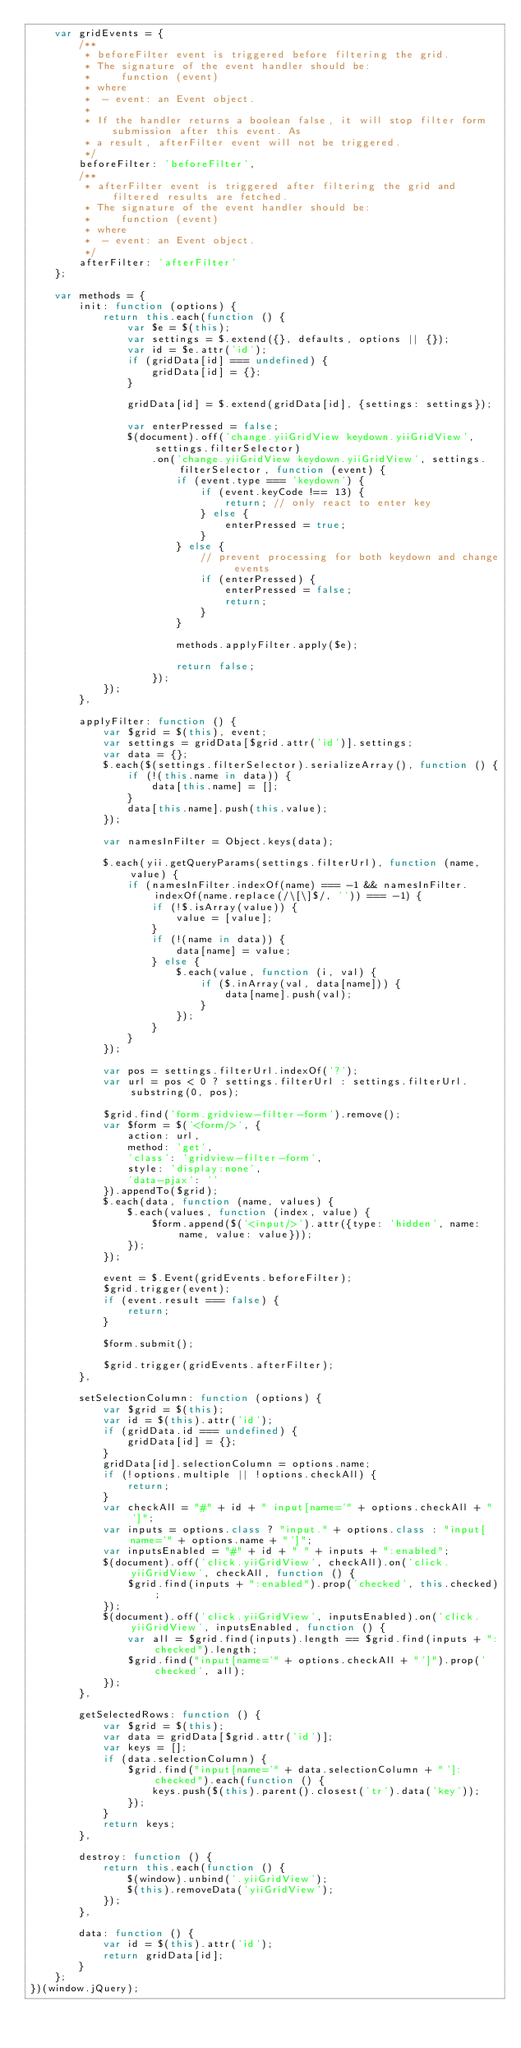<code> <loc_0><loc_0><loc_500><loc_500><_JavaScript_>    var gridEvents = {
        /**
         * beforeFilter event is triggered before filtering the grid.
         * The signature of the event handler should be:
         *     function (event)
         * where
         *  - event: an Event object.
         *
         * If the handler returns a boolean false, it will stop filter form submission after this event. As
         * a result, afterFilter event will not be triggered.
         */
        beforeFilter: 'beforeFilter',
        /**
         * afterFilter event is triggered after filtering the grid and filtered results are fetched.
         * The signature of the event handler should be:
         *     function (event)
         * where
         *  - event: an Event object.
         */
        afterFilter: 'afterFilter'
    };

    var methods = {
        init: function (options) {
            return this.each(function () {
                var $e = $(this);
                var settings = $.extend({}, defaults, options || {});
                var id = $e.attr('id');
                if (gridData[id] === undefined) {
                    gridData[id] = {};
                }

                gridData[id] = $.extend(gridData[id], {settings: settings});

                var enterPressed = false;
                $(document).off('change.yiiGridView keydown.yiiGridView', settings.filterSelector)
                    .on('change.yiiGridView keydown.yiiGridView', settings.filterSelector, function (event) {
                        if (event.type === 'keydown') {
                            if (event.keyCode !== 13) {
                                return; // only react to enter key
                            } else {
                                enterPressed = true;
                            }
                        } else {
                            // prevent processing for both keydown and change events
                            if (enterPressed) {
                                enterPressed = false;
                                return;
                            }
                        }

                        methods.applyFilter.apply($e);

                        return false;
                    });
            });
        },

        applyFilter: function () {
            var $grid = $(this), event;
            var settings = gridData[$grid.attr('id')].settings;
            var data = {};
            $.each($(settings.filterSelector).serializeArray(), function () {
                if (!(this.name in data)) {
                    data[this.name] = [];
                }
                data[this.name].push(this.value);
            });

            var namesInFilter = Object.keys(data);

            $.each(yii.getQueryParams(settings.filterUrl), function (name, value) {
                if (namesInFilter.indexOf(name) === -1 && namesInFilter.indexOf(name.replace(/\[\]$/, '')) === -1) {
                    if (!$.isArray(value)) {
                        value = [value];
                    }
                    if (!(name in data)) {
                        data[name] = value;
                    } else {
                        $.each(value, function (i, val) {
                            if ($.inArray(val, data[name])) {
                                data[name].push(val);
                            }
                        });
                    }
                }
            });

            var pos = settings.filterUrl.indexOf('?');
            var url = pos < 0 ? settings.filterUrl : settings.filterUrl.substring(0, pos);

            $grid.find('form.gridview-filter-form').remove();
            var $form = $('<form/>', {
                action: url,
                method: 'get',
                'class': 'gridview-filter-form',
                style: 'display:none',
                'data-pjax': ''
            }).appendTo($grid);
            $.each(data, function (name, values) {
                $.each(values, function (index, value) {
                    $form.append($('<input/>').attr({type: 'hidden', name: name, value: value}));
                });
            });

            event = $.Event(gridEvents.beforeFilter);
            $grid.trigger(event);
            if (event.result === false) {
                return;
            }

            $form.submit();

            $grid.trigger(gridEvents.afterFilter);
        },

        setSelectionColumn: function (options) {
            var $grid = $(this);
            var id = $(this).attr('id');
            if (gridData.id === undefined) {
                gridData[id] = {};
            }
            gridData[id].selectionColumn = options.name;
            if (!options.multiple || !options.checkAll) {
                return;
            }
            var checkAll = "#" + id + " input[name='" + options.checkAll + "']";
            var inputs = options.class ? "input." + options.class : "input[name='" + options.name + "']";
            var inputsEnabled = "#" + id + " " + inputs + ":enabled";
            $(document).off('click.yiiGridView', checkAll).on('click.yiiGridView', checkAll, function () {
                $grid.find(inputs + ":enabled").prop('checked', this.checked);
            });
            $(document).off('click.yiiGridView', inputsEnabled).on('click.yiiGridView', inputsEnabled, function () {
                var all = $grid.find(inputs).length == $grid.find(inputs + ":checked").length;
                $grid.find("input[name='" + options.checkAll + "']").prop('checked', all);
            });
        },

        getSelectedRows: function () {
            var $grid = $(this);
            var data = gridData[$grid.attr('id')];
            var keys = [];
            if (data.selectionColumn) {
                $grid.find("input[name='" + data.selectionColumn + "']:checked").each(function () {
                    keys.push($(this).parent().closest('tr').data('key'));
                });
            }
            return keys;
        },

        destroy: function () {
            return this.each(function () {
                $(window).unbind('.yiiGridView');
                $(this).removeData('yiiGridView');
            });
        },

        data: function () {
            var id = $(this).attr('id');
            return gridData[id];
        }
    };
})(window.jQuery);
</code> 